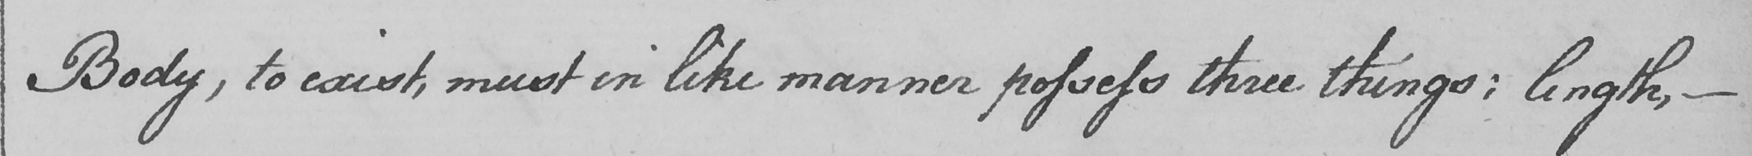What text is written in this handwritten line? Body , to exist , must in like manner possess three things :  length ,  _ 